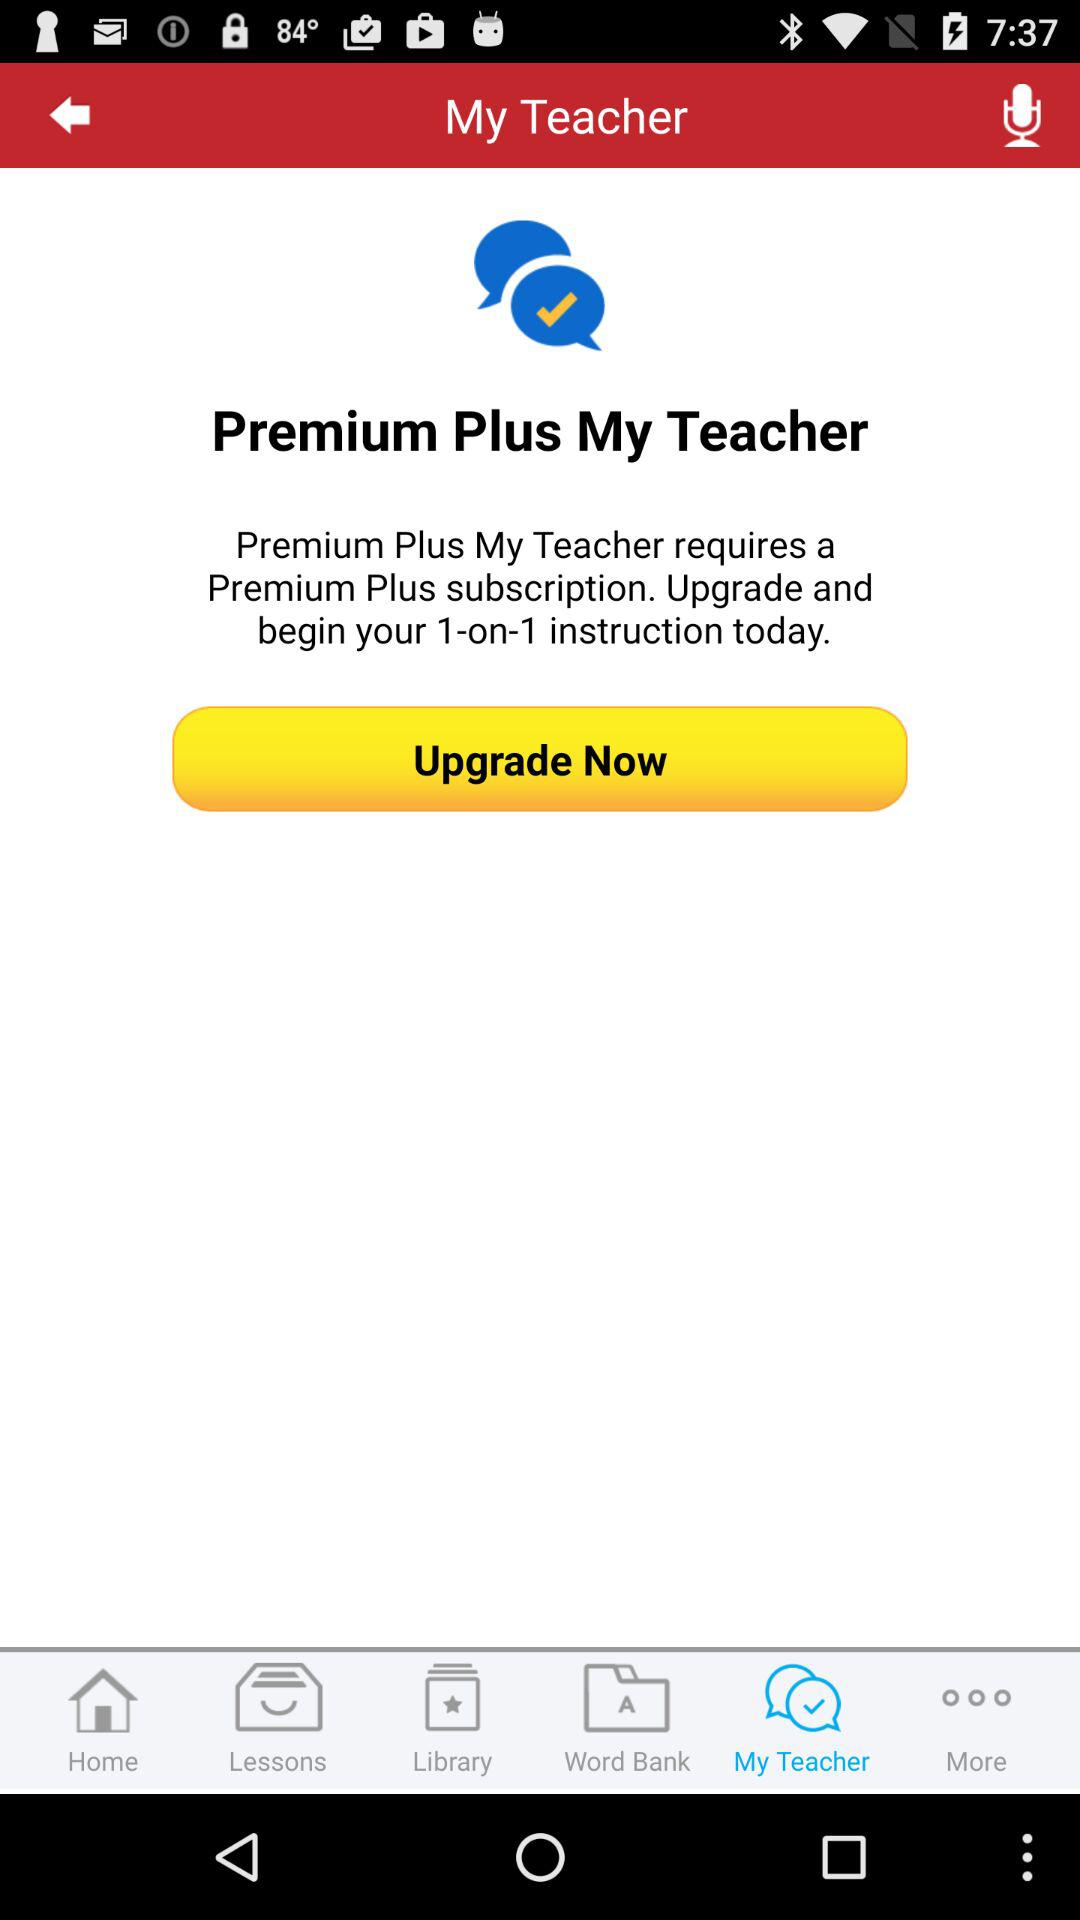What is the name of the application? The name of the application is "My Teacher". 